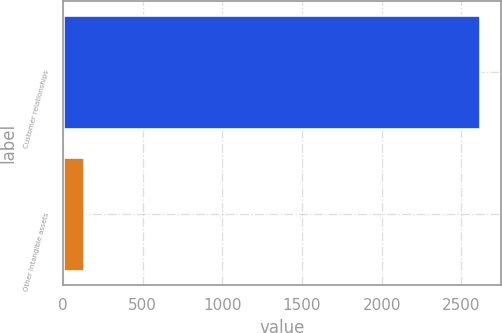Convert chart. <chart><loc_0><loc_0><loc_500><loc_500><bar_chart><fcel>Customer relationships<fcel>Other intangible assets<nl><fcel>2617<fcel>130<nl></chart> 